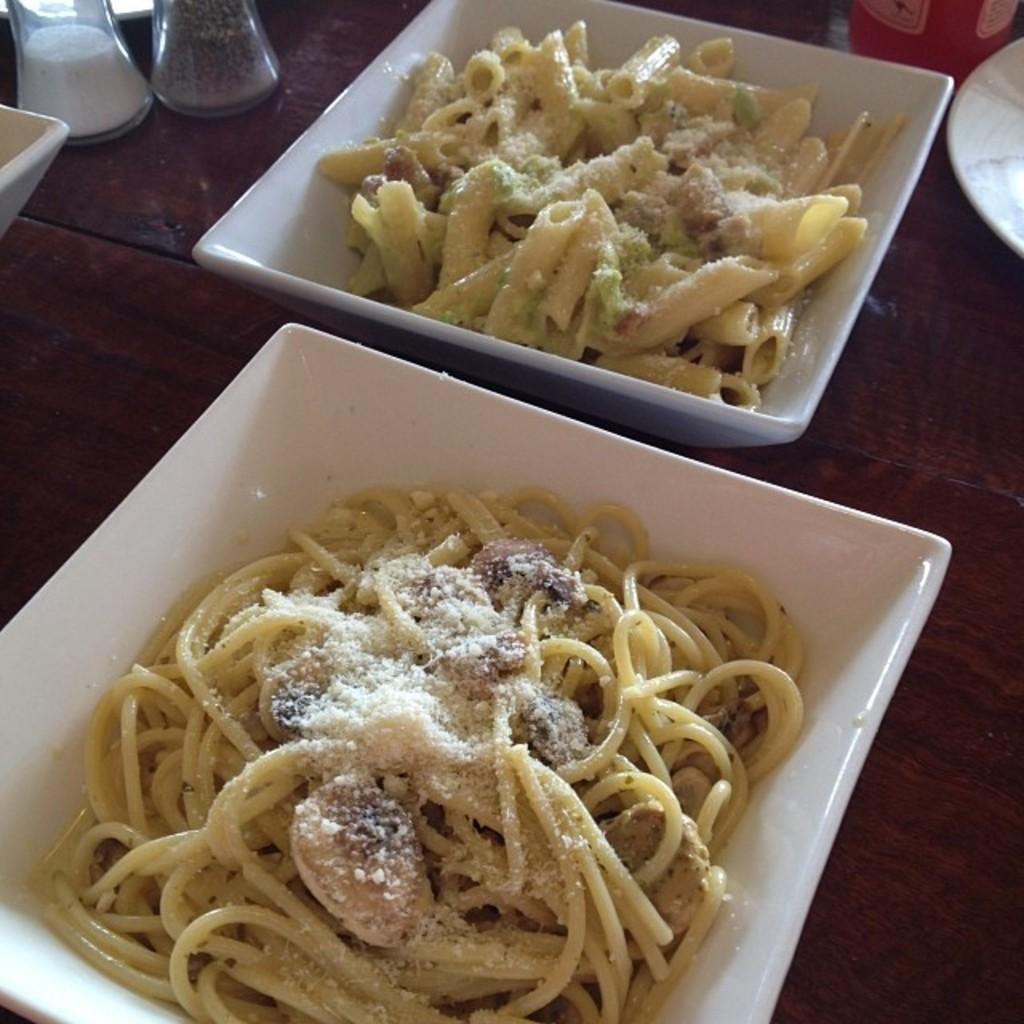How many bowls are visible in the image? There are two bowls in the image. What is inside the bowls? The bowls contain food items. What type of containers are present in the image? There are glass bottles in the image. What is the surface on which the items are placed? The items are placed on a wooden table in the image. How does the knowledge in the image help to unlock the door? There is no mention of knowledge or a door in the image; it only contains two bowls, glass bottles, and a wooden table. 